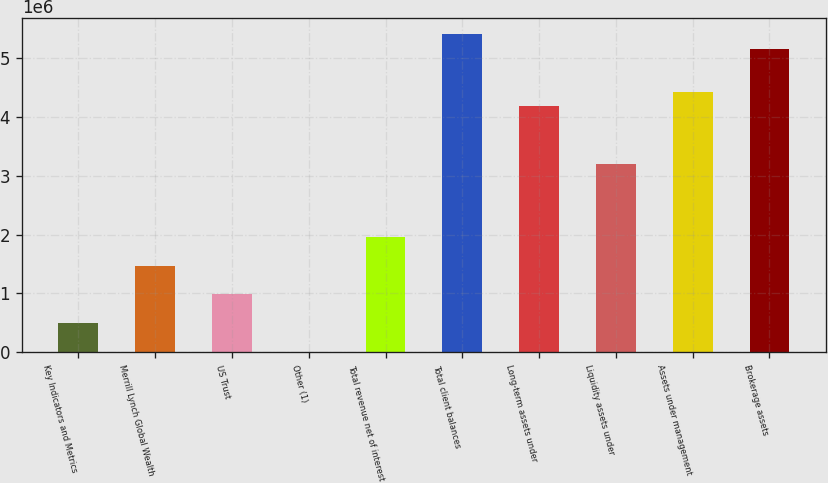Convert chart to OTSL. <chart><loc_0><loc_0><loc_500><loc_500><bar_chart><fcel>Key Indicators and Metrics<fcel>Merrill Lynch Global Wealth<fcel>US Trust<fcel>Other (1)<fcel>Total revenue net of interest<fcel>Total client balances<fcel>Long-term assets under<fcel>Liquidity assets under<fcel>Assets under management<fcel>Brokerage assets<nl><fcel>491429<fcel>1.47414e+06<fcel>982782<fcel>76<fcel>1.96549e+06<fcel>5.40496e+06<fcel>4.17658e+06<fcel>3.19387e+06<fcel>4.42225e+06<fcel>5.15928e+06<nl></chart> 